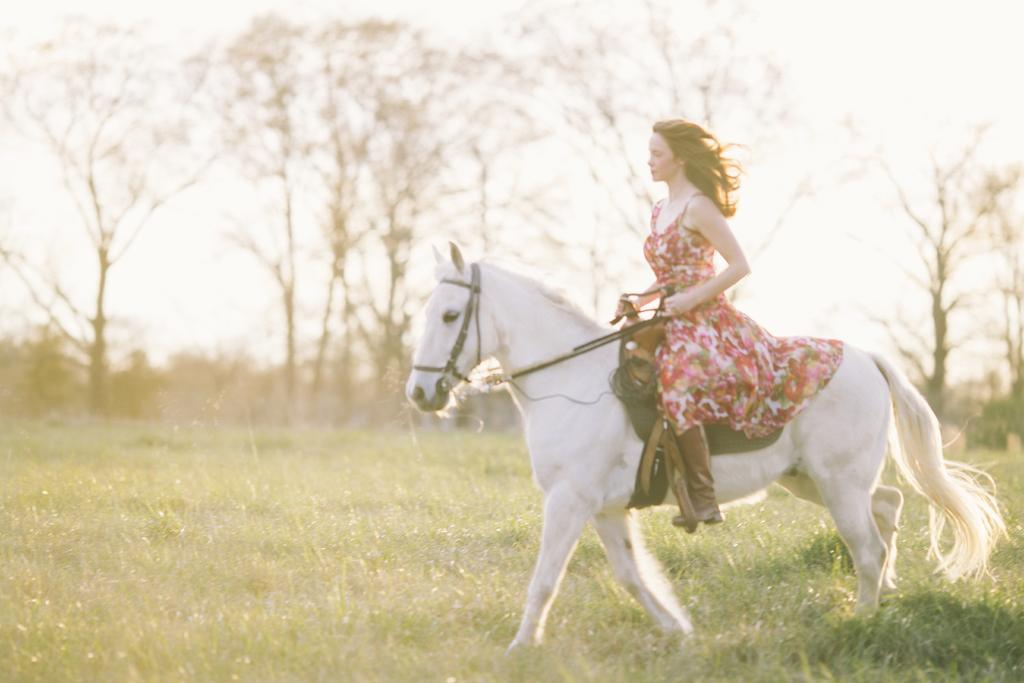Who is the main subject in the image? There is a woman in the image. What is the woman doing in the image? The woman is riding a horse. What can be seen in the background of the image? There are trees and the sky visible in the background of the image. What type of wood is being used to build the room in the image? There is no room present in the image, so it is not possible to determine what type of wood might be used in its construction. 